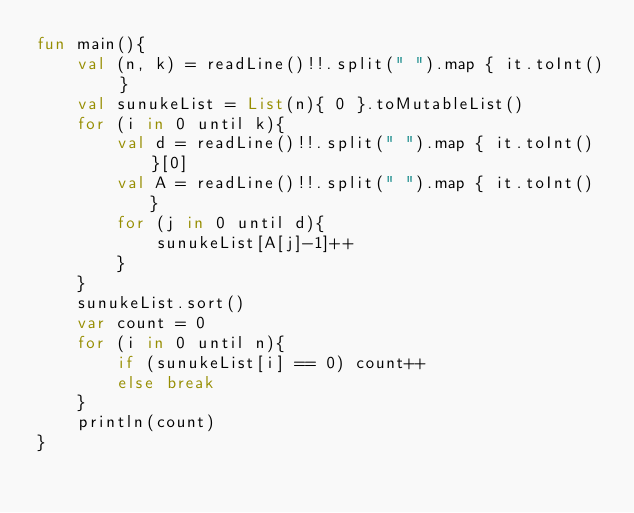<code> <loc_0><loc_0><loc_500><loc_500><_Kotlin_>fun main(){
    val (n, k) = readLine()!!.split(" ").map { it.toInt() }
    val sunukeList = List(n){ 0 }.toMutableList()
    for (i in 0 until k){
        val d = readLine()!!.split(" ").map { it.toInt() }[0]
        val A = readLine()!!.split(" ").map { it.toInt() }
        for (j in 0 until d){
            sunukeList[A[j]-1]++
        }
    }
    sunukeList.sort()
    var count = 0
    for (i in 0 until n){
        if (sunukeList[i] == 0) count++
        else break
    }
    println(count)
}
</code> 